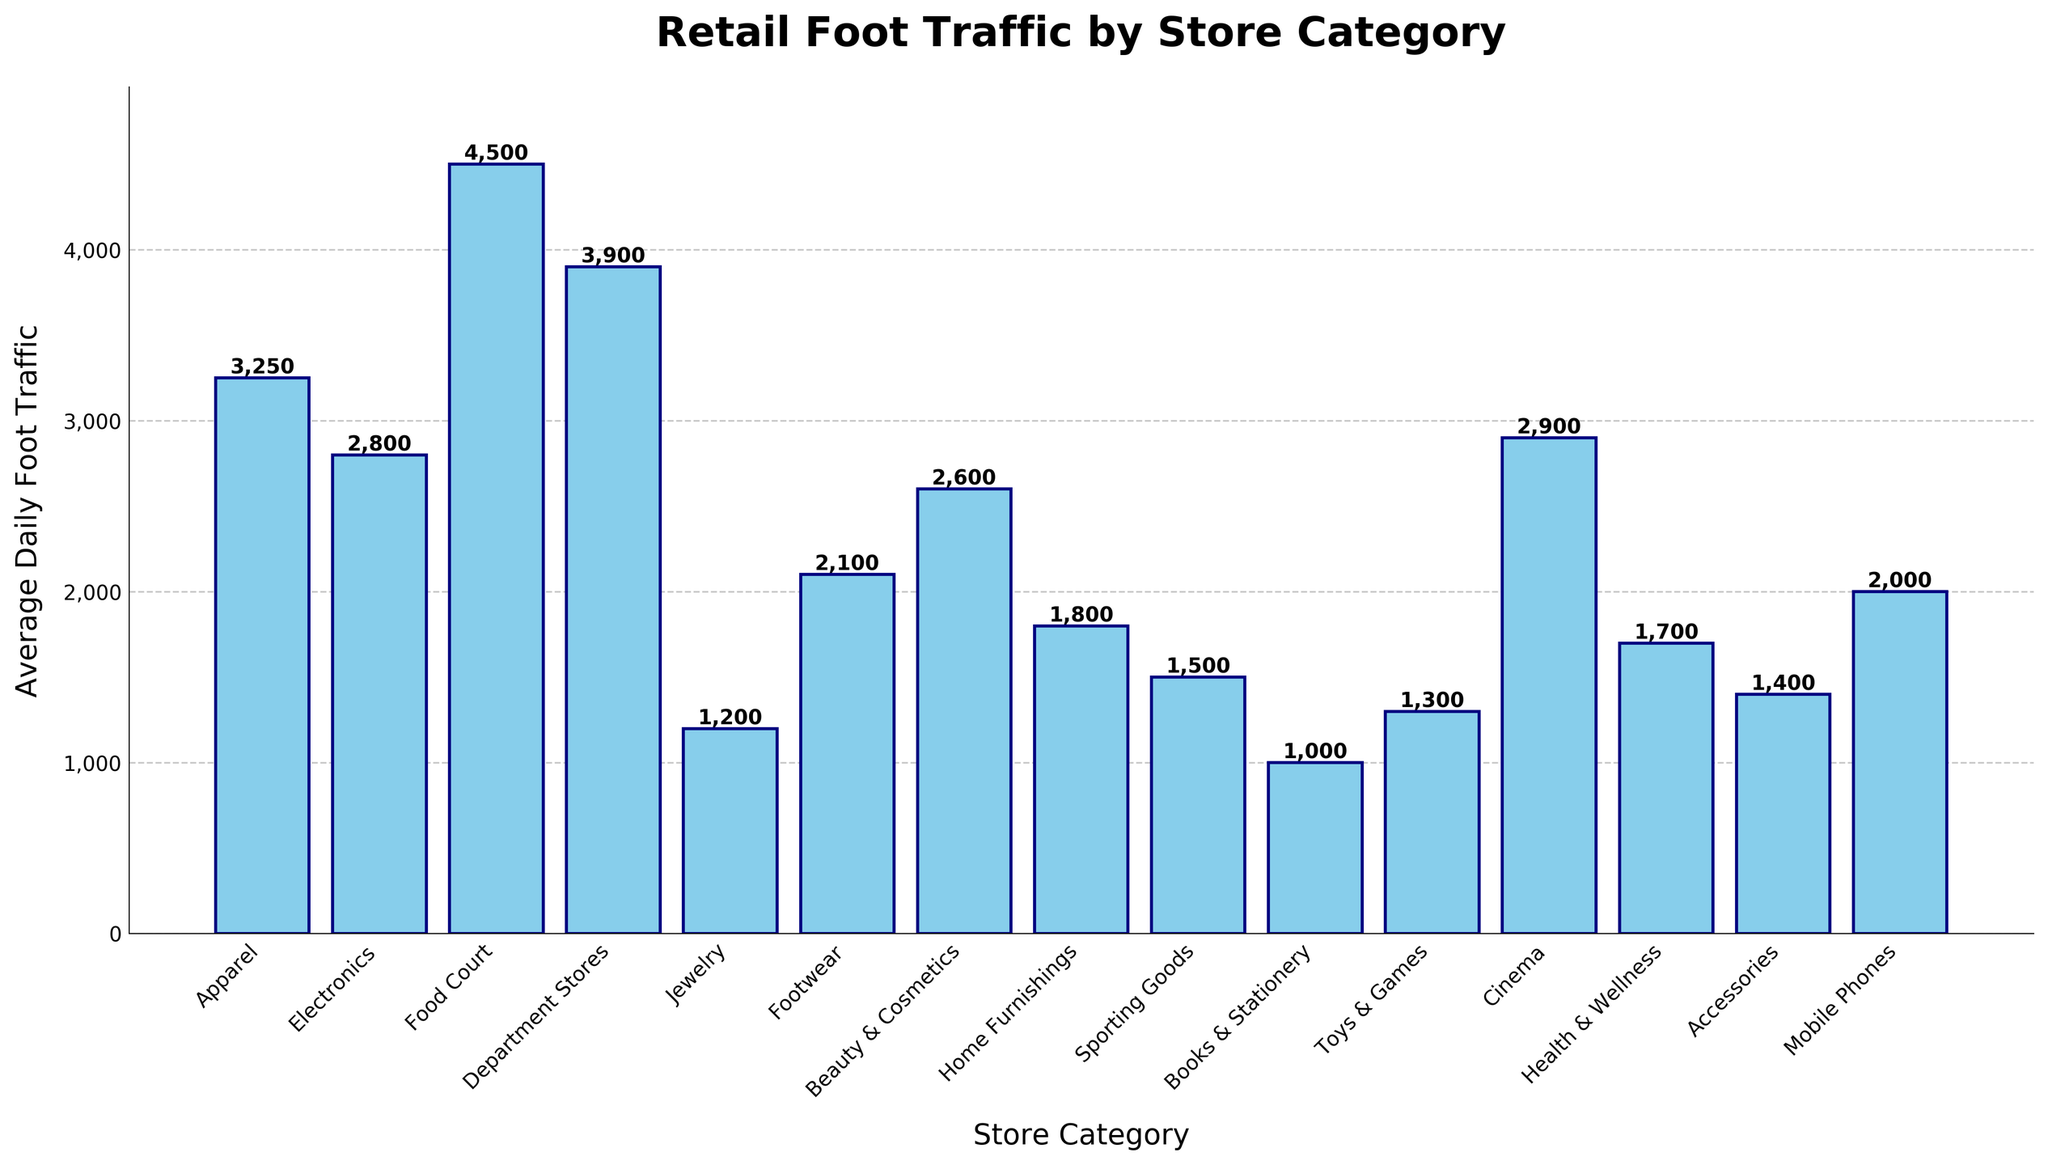What store category receives the highest average daily foot traffic? To identify the store category with the highest average daily foot traffic, look for the tallest bar in the chart and note the corresponding category on the x-axis.
Answer: Food Court Which store categories have an average daily foot traffic above 3,000? Scan the chart and identify bars that extend above the 3,000 line on the y-axis, then list the corresponding categories.
Answer: Apparel, Food Court, Department Stores What's the combined average daily foot traffic for Health & Wellness and Beauty & Cosmetics? Find the height values for Health & Wellness (1,700) and Beauty & Cosmetics (2,600), then sum these values: 1,700 + 2,600.
Answer: 4,300 How does the average daily foot traffic for Cinema compare with Electronics? Find the bar heights for Cinema (2,900) and Electronics (2,800) and compare their magnitudes.
Answer: Cinema has higher traffic than Electronics Which category has the least average daily foot traffic, and what is its value? Identify the shortest bar on the chart and note the corresponding category and its height value.
Answer: Books & Stationery, 1,000 Is the average daily foot traffic for Mobile Phones greater than that for Footwear? Look at the bar heights for Mobile Phones (2,000) and Footwear (2,100) and compare them.
Answer: No, Footwear has higher traffic What's the difference in average daily foot traffic between Department Stores and Sporting Goods? Find the values for Department Stores (3,900) and Sporting Goods (1,500). Subtract the smaller value from the larger one: 3,900 - 1,500.
Answer: 2,400 What's the average daily foot traffic for the top three categories combined? Identify the three categories with the highest foot traffic (Food Court, Department Stores, and Apparel). Sum their values: 4,500 + 3,900 + 3,250.
Answer: 11,650 Which categories have an average daily foot traffic between 1,000 and 2,000? Identify bars with heights ranging between 1,000 and 2,000 and list the corresponding categories.
Answer: Home Furnishings, Sporting Goods, Health & Wellness, Accessories, Mobile Phones, Jewelry, Toys & Games What is the total average daily foot traffic captured by the categories with bars shorter than 2,000? Sum the foot traffic values for categories with bars shorter than 2,000: Jewelry (1,200), Home Furnishings (1,800), Sporting Goods (1,500), Books & Stationery (1,000), Toys & Games (1,300), Health & Wellness (1,700), and Accessories (1,400).
Answer: 9,900 